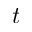<formula> <loc_0><loc_0><loc_500><loc_500>t</formula> 